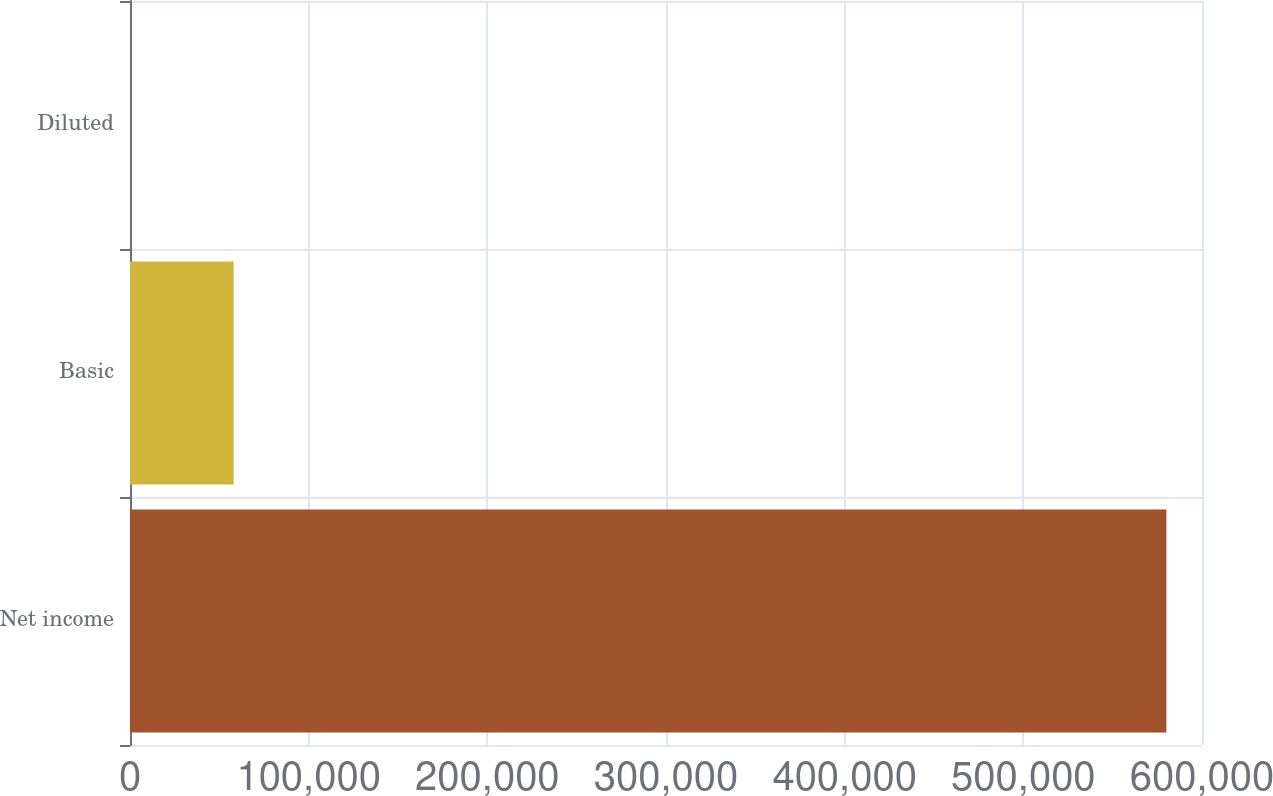<chart> <loc_0><loc_0><loc_500><loc_500><bar_chart><fcel>Net income<fcel>Basic<fcel>Diluted<nl><fcel>580064<fcel>58009.2<fcel>3.15<nl></chart> 